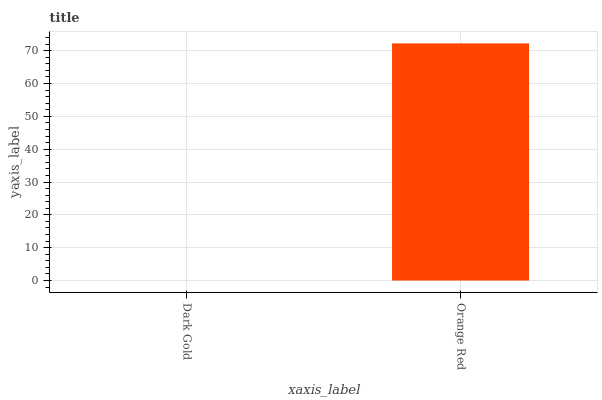Is Dark Gold the minimum?
Answer yes or no. Yes. Is Orange Red the maximum?
Answer yes or no. Yes. Is Orange Red the minimum?
Answer yes or no. No. Is Orange Red greater than Dark Gold?
Answer yes or no. Yes. Is Dark Gold less than Orange Red?
Answer yes or no. Yes. Is Dark Gold greater than Orange Red?
Answer yes or no. No. Is Orange Red less than Dark Gold?
Answer yes or no. No. Is Orange Red the high median?
Answer yes or no. Yes. Is Dark Gold the low median?
Answer yes or no. Yes. Is Dark Gold the high median?
Answer yes or no. No. Is Orange Red the low median?
Answer yes or no. No. 